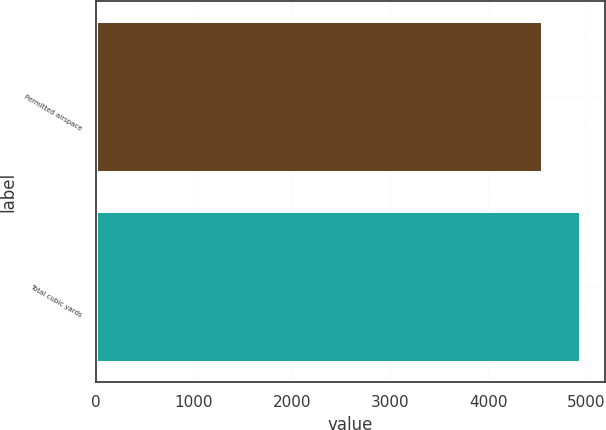Convert chart. <chart><loc_0><loc_0><loc_500><loc_500><bar_chart><fcel>Permitted airspace<fcel>Total cubic yards<nl><fcel>4559.6<fcel>4945.8<nl></chart> 